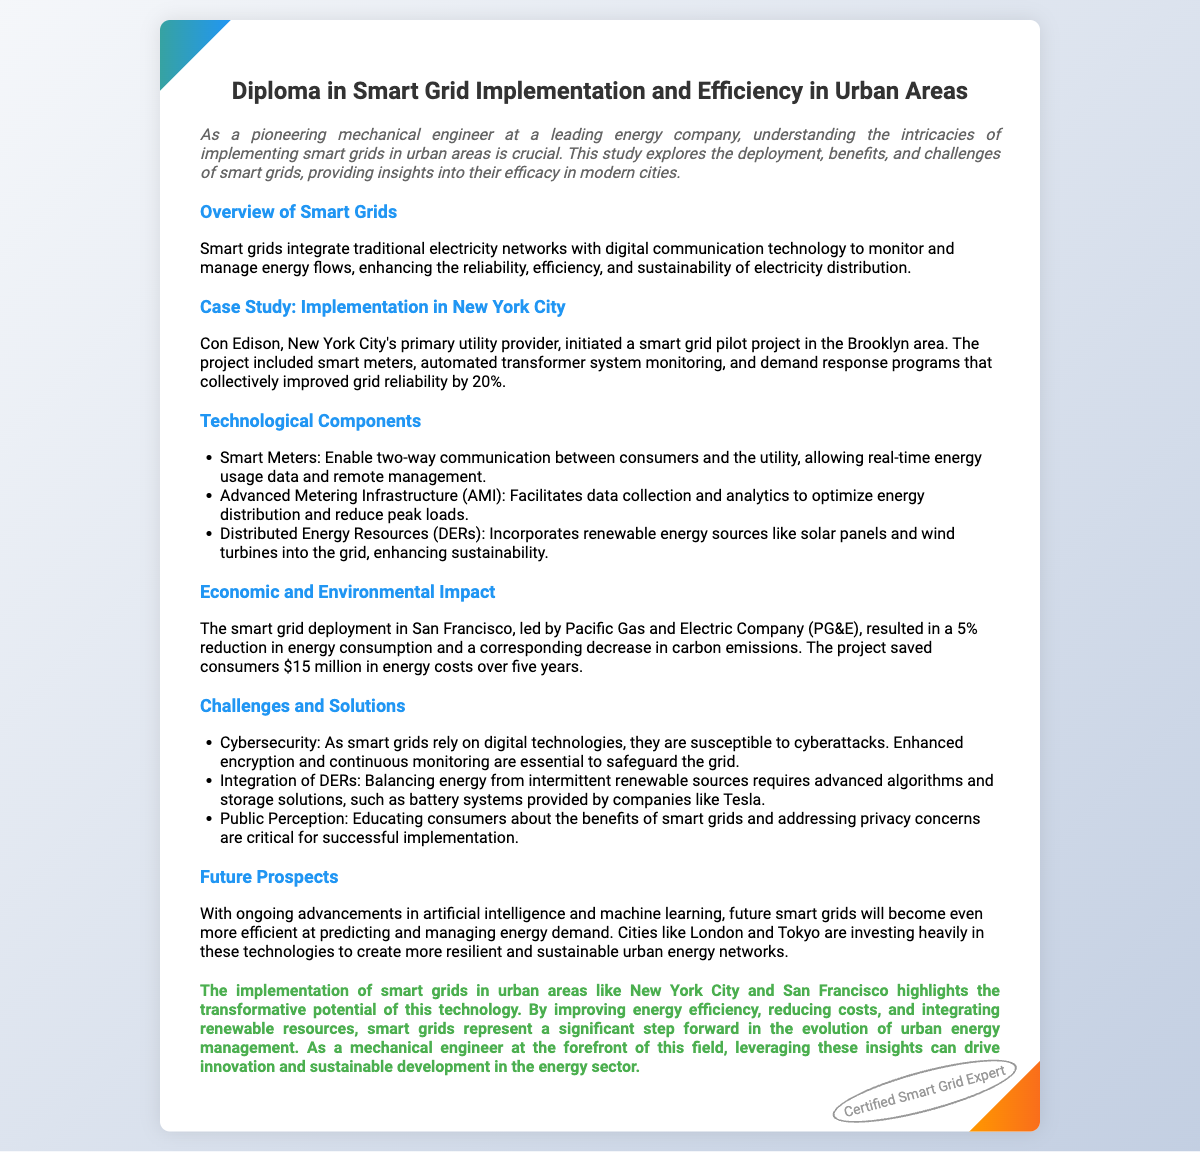What is the title of the diploma? The title of the diploma is displayed prominently at the top of the document.
Answer: Diploma in Smart Grid Implementation and Efficiency in Urban Areas Which city initiated a smart grid pilot project? The document mentions the case study of Con Edison, which is based in New York City.
Answer: New York City What was the percentage increase in grid reliability due to the pilot project? The document states that the pilot project improved grid reliability by 20%.
Answer: 20% How much did smart grid deployment in San Francisco reduce energy consumption? The document specifies that the smart grid deployment led to a 5% reduction in energy consumption in San Francisco.
Answer: 5% What is one technological component essential for smart grids? The document lists technological components and mentions smart meters as one essential component.
Answer: Smart Meters What is a major challenge related to smart grid cybersecurity? The document identifies susceptibility to cyberattacks as a significant challenge for smart grids.
Answer: Cyberattacks What did the residents save in energy costs over five years in San Francisco? According to the document, the project saved consumers $15 million in energy costs over five years.
Answer: $15 million What future advancements are mentioned that could enhance smart grids? The document mentions advancements in artificial intelligence and machine learning that will improve future smart grids.
Answer: Artificial intelligence and machine learning What is the significance of public perception in smart grid implementation? The document discusses educating consumers about the benefits of smart grids as crucial for success.
Answer: Educating consumers 